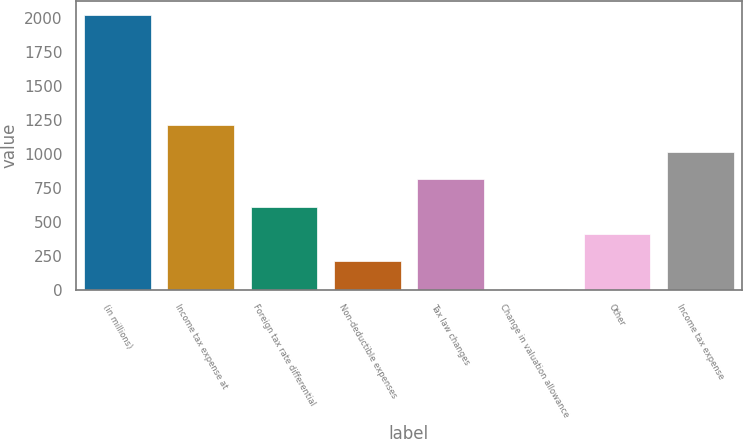Convert chart to OTSL. <chart><loc_0><loc_0><loc_500><loc_500><bar_chart><fcel>(in millions)<fcel>Income tax expense at<fcel>Foreign tax rate differential<fcel>Non-deductible expenses<fcel>Tax law changes<fcel>Change in valuation allowance<fcel>Other<fcel>Income tax expense<nl><fcel>2018<fcel>1212.92<fcel>609.11<fcel>206.57<fcel>810.38<fcel>5.3<fcel>407.84<fcel>1011.65<nl></chart> 